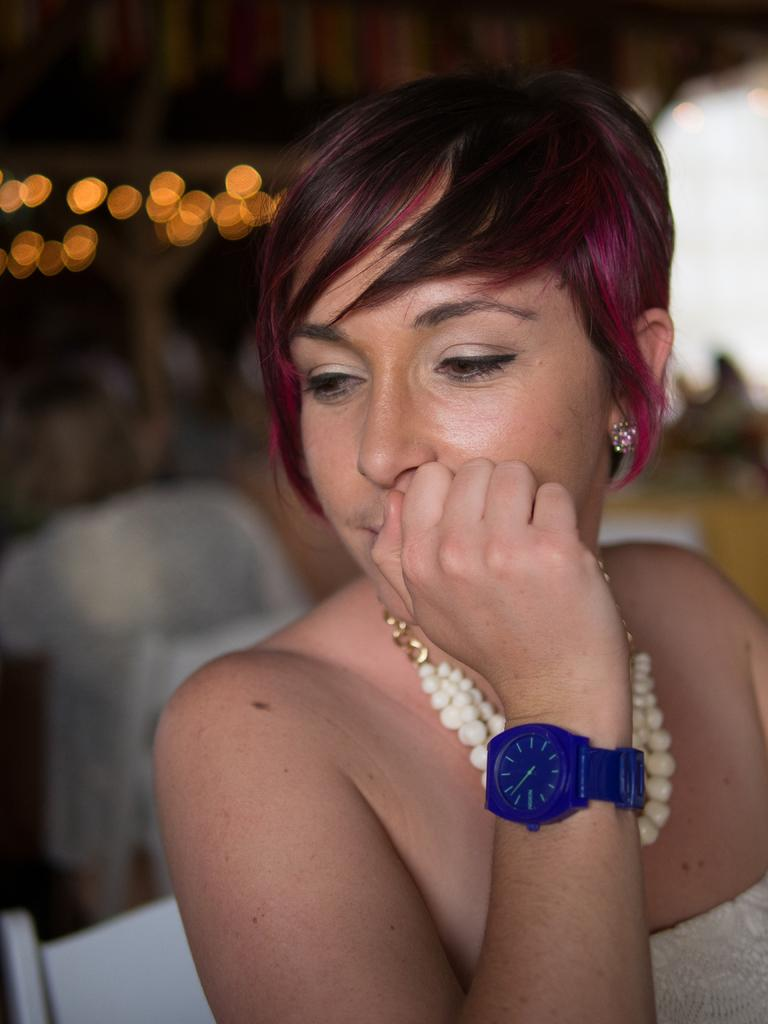What is the woman doing in the image? The woman is sitting on a chair in the image. How many people are sitting on chairs in the image? There are two people sitting on chairs in the image. What can be seen in the background or surroundings of the image? There are lights visible in the image. What type of coat is the woman wearing in the image? There is no coat mentioned or visible in the image. What rail is present in the image? There is no rail present in the image. 